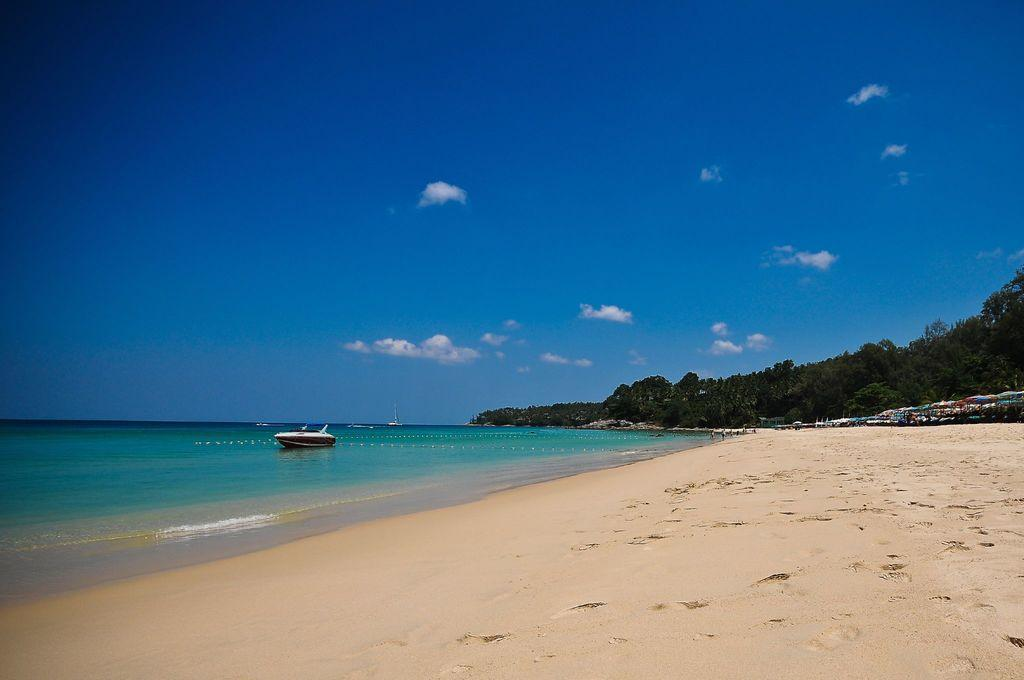What type of terrain is visible in the image? There is sand and water visible in the image. What object can be seen floating on the water? There is a boat in the image. What type of vegetation is present in the image? There are trees in the image. Who or what is present in the image? There are people in the image. What is visible in the sky in the image? The sky is visible in the image, and clouds are present. What type of juice is being served to the people in the image? There is no juice present in the image; it features sand, water, a boat, trees, people, the sky, and clouds. Who is the coach of the people in the image? There is no coach present in the image; it features sand, water, a boat, trees, people, the sky, and clouds. 